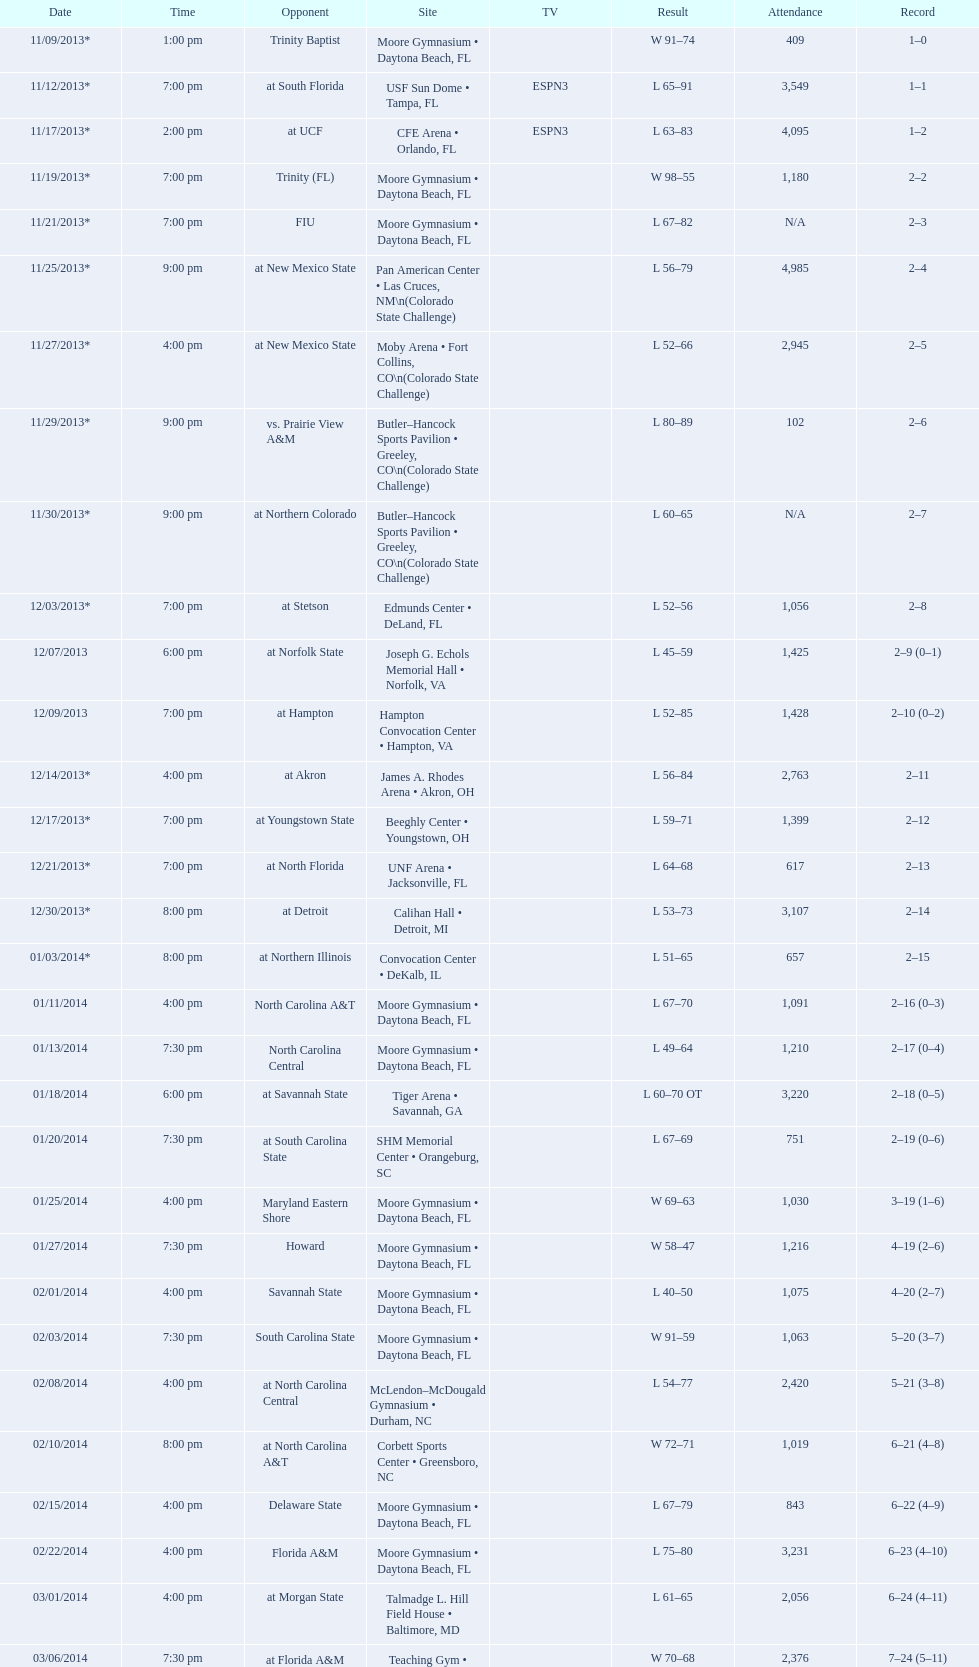How many teams had no more than 1,000 in attendance? 6. 